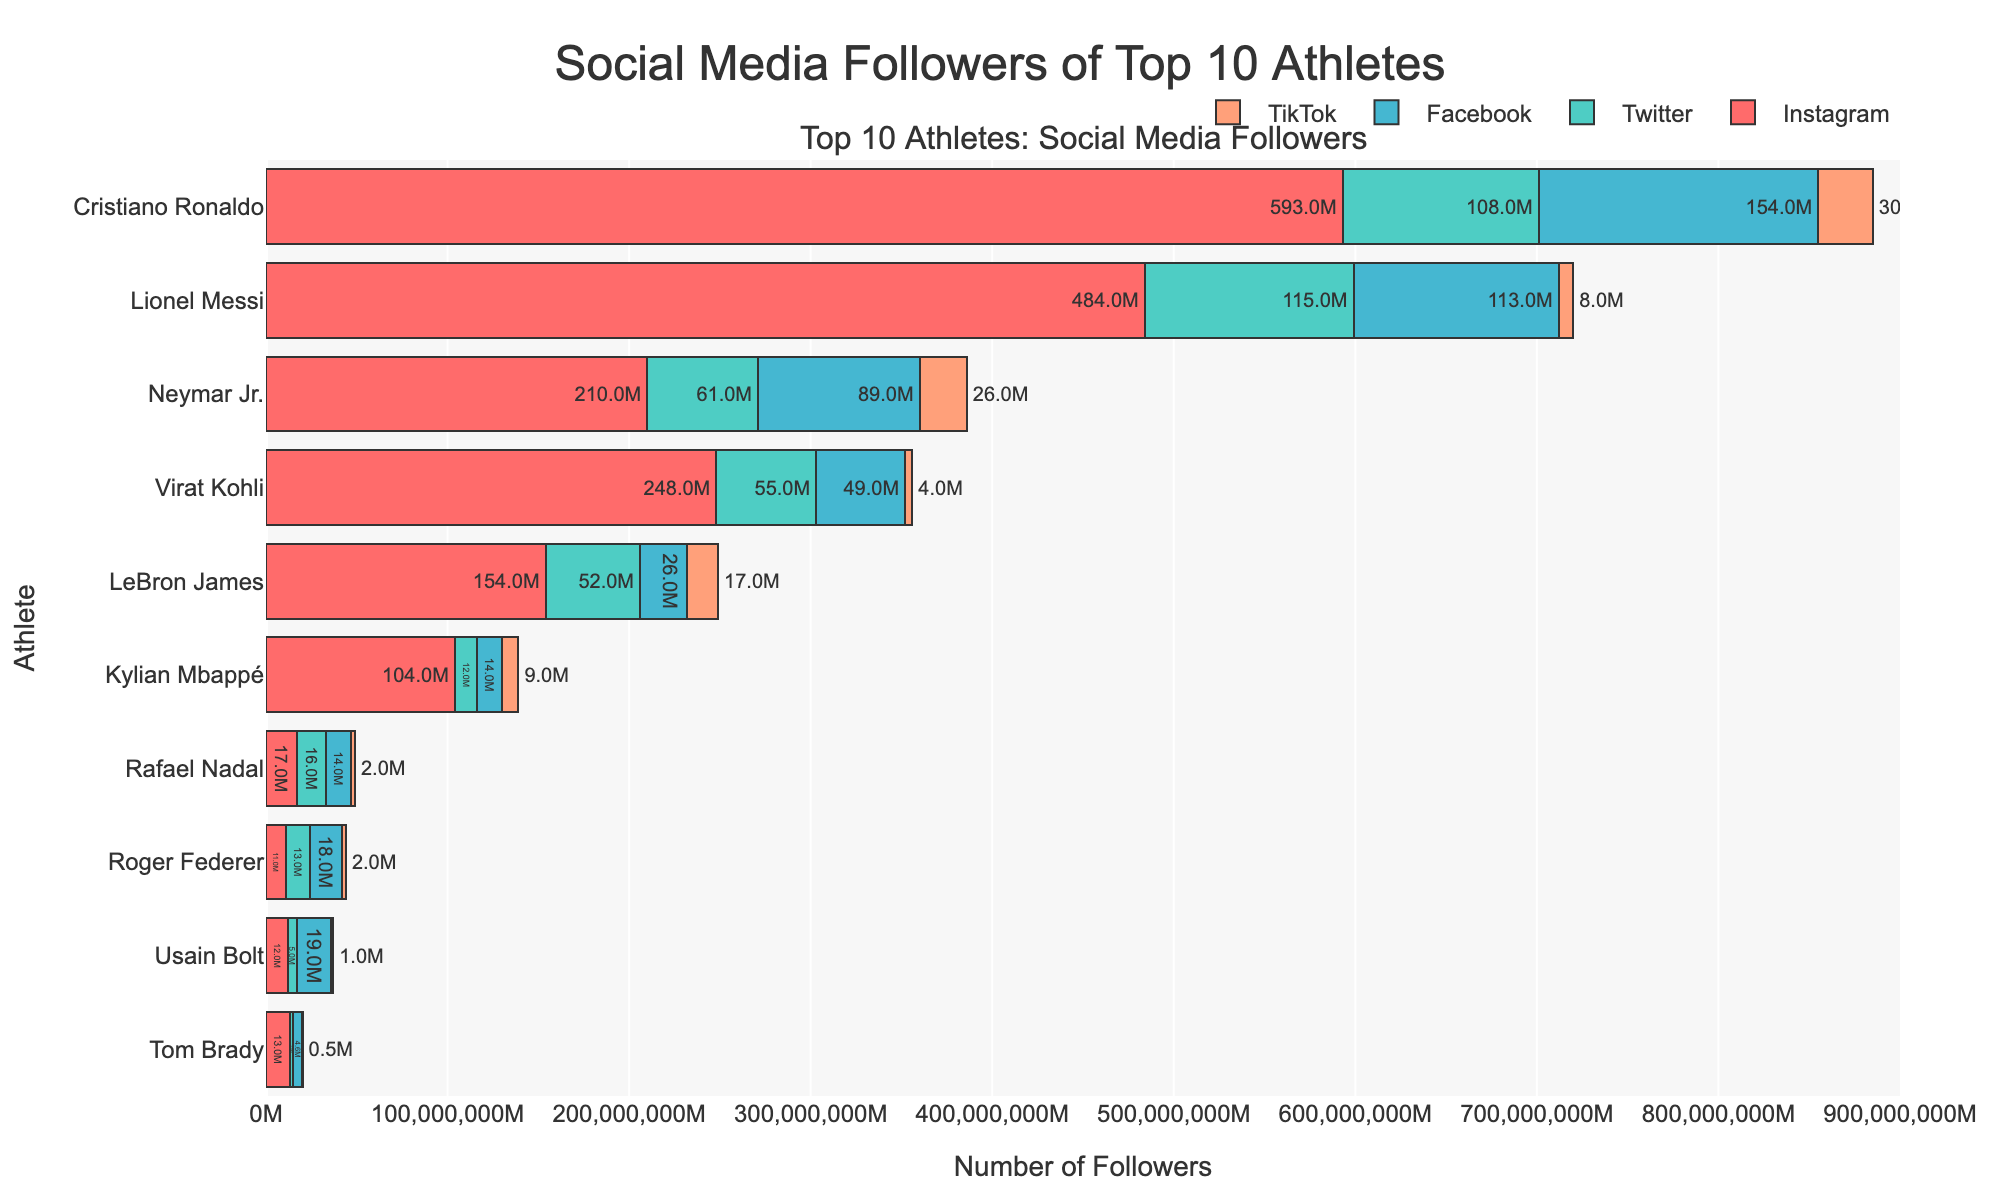Which athlete has the highest number of followers on Instagram? By looking at the longest bar for the Instagram category, it's clear that Cristiano Ronaldo has the highest number of followers with 593 million.
Answer: Cristiano Ronaldo How many followers does Lionel Messi have in total across all platforms? Add Messi's followers from Instagram (484M), Twitter (115M), Facebook (113M), and TikTok (8M). The total is 484M + 115M + 113M + 8M = 720M.
Answer: 720M Which platforms have more followers for Neymar Jr. compared to LeBron James? Compare their follower counts on Instagram, Twitter, Facebook, and TikTok. Neymar Jr. has 210M on Instagram compared to LeBron's 154M; 61M on Twitter compared to 52M; 89M on Facebook compared to 26M; and 26M on TikTok compared to LeBron's 17M. Therefore, Neymar surpasses LeBron on all platforms.
Answer: All platforms Between Roger Federer and Rafael Nadal, who has more followers on Facebook? Compare the lengths of their bars in the Facebook category. Roger Federer has 18M while Rafael Nadal has 14M. Roger has more followers on Facebook.
Answer: Roger Federer On which platform does Cristiano Ronaldo have the least followers? Examine the bars for Cristiano Ronaldo across all platforms and identify the shortest one. The TikTok bar is the shortest with 30M.
Answer: TikTok What is the combined total followers of Usain Bolt across Instagram and Facebook? Add Usain Bolt's followers from Instagram (12M) and Facebook (19M). The total is 12M + 19M = 31M.
Answer: 31M Who has more followers on Twitter: Tom Brady or Kylian Mbappé? Compare the lengths of their bars in the Twitter category. Tom Brady has 2M and Kylian Mbappé has 12M. Kylian Mbappé has more followers.
Answer: Kylian Mbappé Which athlete has the highest followers on TikTok? By looking for the longest bar in the TikTok category, Cristiano Ronaldo has the highest with 30M followers.
Answer: Cristiano Ronaldo How many more Instagram followers does Virat Kohli have compared to Roger Federer? Subtract Federer's Instagram followers (11M) from Kohli's (248M). The difference is 248M - 11M = 237M.
Answer: 237M For LeBron James, which is greater: his followers on Instagram or the combined total of his followers on Twitter, Facebook, and TikTok? Compare LeBron's Instagram followers (154M) to the sum of his other platforms: Twitter (52M), Facebook (26M), and TikTok (17M). The total of the latter three is 52M + 26M + 17M = 95M. Thus, his Instagram followers are greater.
Answer: Instagram 